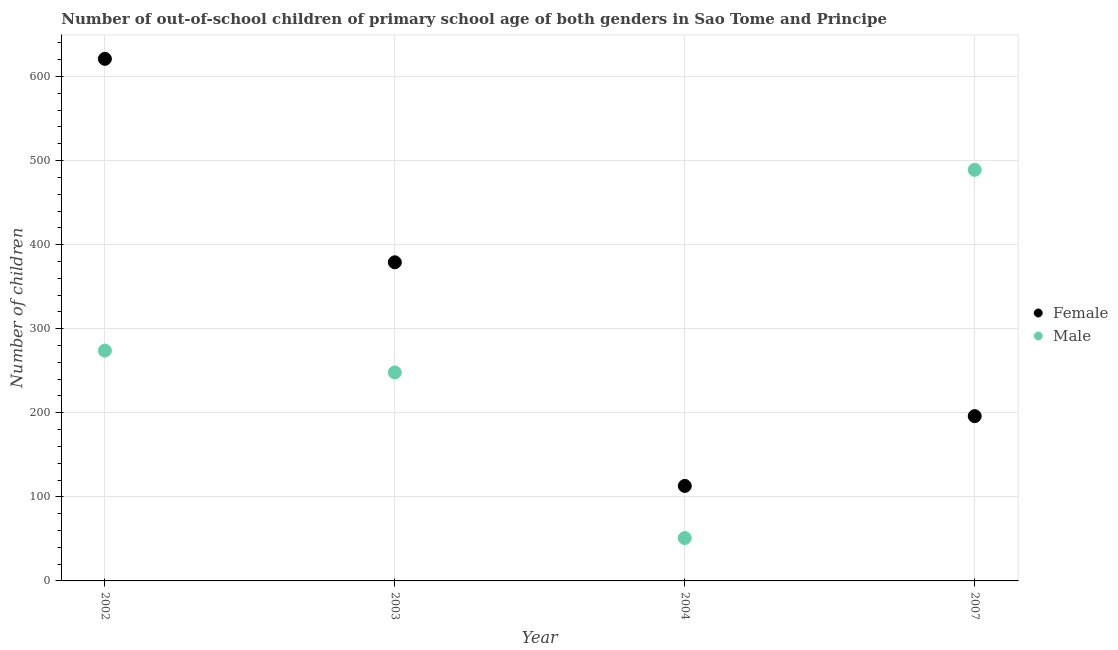Is the number of dotlines equal to the number of legend labels?
Your response must be concise. Yes. What is the number of female out-of-school students in 2007?
Offer a very short reply. 196. Across all years, what is the maximum number of female out-of-school students?
Your answer should be very brief. 621. Across all years, what is the minimum number of female out-of-school students?
Your response must be concise. 113. In which year was the number of female out-of-school students minimum?
Provide a succinct answer. 2004. What is the total number of male out-of-school students in the graph?
Give a very brief answer. 1062. What is the difference between the number of male out-of-school students in 2003 and that in 2004?
Give a very brief answer. 197. What is the difference between the number of male out-of-school students in 2007 and the number of female out-of-school students in 2004?
Make the answer very short. 376. What is the average number of female out-of-school students per year?
Offer a terse response. 327.25. In the year 2007, what is the difference between the number of male out-of-school students and number of female out-of-school students?
Offer a terse response. 293. What is the ratio of the number of female out-of-school students in 2002 to that in 2004?
Your answer should be compact. 5.5. Is the number of female out-of-school students in 2002 less than that in 2004?
Make the answer very short. No. What is the difference between the highest and the second highest number of male out-of-school students?
Your answer should be compact. 215. What is the difference between the highest and the lowest number of male out-of-school students?
Keep it short and to the point. 438. In how many years, is the number of male out-of-school students greater than the average number of male out-of-school students taken over all years?
Offer a very short reply. 2. Is the sum of the number of female out-of-school students in 2002 and 2003 greater than the maximum number of male out-of-school students across all years?
Offer a very short reply. Yes. Does the number of female out-of-school students monotonically increase over the years?
Keep it short and to the point. No. How many dotlines are there?
Ensure brevity in your answer.  2. What is the difference between two consecutive major ticks on the Y-axis?
Keep it short and to the point. 100. Are the values on the major ticks of Y-axis written in scientific E-notation?
Your response must be concise. No. Does the graph contain any zero values?
Give a very brief answer. No. Where does the legend appear in the graph?
Your answer should be very brief. Center right. What is the title of the graph?
Give a very brief answer. Number of out-of-school children of primary school age of both genders in Sao Tome and Principe. What is the label or title of the Y-axis?
Your answer should be compact. Number of children. What is the Number of children in Female in 2002?
Give a very brief answer. 621. What is the Number of children of Male in 2002?
Your response must be concise. 274. What is the Number of children of Female in 2003?
Provide a succinct answer. 379. What is the Number of children in Male in 2003?
Your response must be concise. 248. What is the Number of children in Female in 2004?
Provide a succinct answer. 113. What is the Number of children in Female in 2007?
Keep it short and to the point. 196. What is the Number of children of Male in 2007?
Your answer should be very brief. 489. Across all years, what is the maximum Number of children of Female?
Ensure brevity in your answer.  621. Across all years, what is the maximum Number of children of Male?
Make the answer very short. 489. Across all years, what is the minimum Number of children of Female?
Your answer should be compact. 113. What is the total Number of children of Female in the graph?
Offer a very short reply. 1309. What is the total Number of children of Male in the graph?
Provide a short and direct response. 1062. What is the difference between the Number of children in Female in 2002 and that in 2003?
Ensure brevity in your answer.  242. What is the difference between the Number of children of Female in 2002 and that in 2004?
Your answer should be very brief. 508. What is the difference between the Number of children of Male in 2002 and that in 2004?
Provide a short and direct response. 223. What is the difference between the Number of children of Female in 2002 and that in 2007?
Provide a short and direct response. 425. What is the difference between the Number of children in Male in 2002 and that in 2007?
Your answer should be compact. -215. What is the difference between the Number of children of Female in 2003 and that in 2004?
Give a very brief answer. 266. What is the difference between the Number of children in Male in 2003 and that in 2004?
Your answer should be compact. 197. What is the difference between the Number of children of Female in 2003 and that in 2007?
Make the answer very short. 183. What is the difference between the Number of children in Male in 2003 and that in 2007?
Give a very brief answer. -241. What is the difference between the Number of children in Female in 2004 and that in 2007?
Provide a short and direct response. -83. What is the difference between the Number of children of Male in 2004 and that in 2007?
Your answer should be very brief. -438. What is the difference between the Number of children in Female in 2002 and the Number of children in Male in 2003?
Offer a very short reply. 373. What is the difference between the Number of children of Female in 2002 and the Number of children of Male in 2004?
Offer a terse response. 570. What is the difference between the Number of children in Female in 2002 and the Number of children in Male in 2007?
Offer a terse response. 132. What is the difference between the Number of children of Female in 2003 and the Number of children of Male in 2004?
Offer a terse response. 328. What is the difference between the Number of children in Female in 2003 and the Number of children in Male in 2007?
Make the answer very short. -110. What is the difference between the Number of children in Female in 2004 and the Number of children in Male in 2007?
Offer a terse response. -376. What is the average Number of children of Female per year?
Your response must be concise. 327.25. What is the average Number of children of Male per year?
Offer a very short reply. 265.5. In the year 2002, what is the difference between the Number of children in Female and Number of children in Male?
Offer a very short reply. 347. In the year 2003, what is the difference between the Number of children in Female and Number of children in Male?
Offer a very short reply. 131. In the year 2004, what is the difference between the Number of children in Female and Number of children in Male?
Give a very brief answer. 62. In the year 2007, what is the difference between the Number of children of Female and Number of children of Male?
Give a very brief answer. -293. What is the ratio of the Number of children in Female in 2002 to that in 2003?
Offer a very short reply. 1.64. What is the ratio of the Number of children in Male in 2002 to that in 2003?
Your response must be concise. 1.1. What is the ratio of the Number of children in Female in 2002 to that in 2004?
Give a very brief answer. 5.5. What is the ratio of the Number of children of Male in 2002 to that in 2004?
Offer a terse response. 5.37. What is the ratio of the Number of children in Female in 2002 to that in 2007?
Give a very brief answer. 3.17. What is the ratio of the Number of children in Male in 2002 to that in 2007?
Make the answer very short. 0.56. What is the ratio of the Number of children in Female in 2003 to that in 2004?
Ensure brevity in your answer.  3.35. What is the ratio of the Number of children in Male in 2003 to that in 2004?
Provide a succinct answer. 4.86. What is the ratio of the Number of children in Female in 2003 to that in 2007?
Offer a terse response. 1.93. What is the ratio of the Number of children in Male in 2003 to that in 2007?
Keep it short and to the point. 0.51. What is the ratio of the Number of children of Female in 2004 to that in 2007?
Your response must be concise. 0.58. What is the ratio of the Number of children of Male in 2004 to that in 2007?
Ensure brevity in your answer.  0.1. What is the difference between the highest and the second highest Number of children in Female?
Your response must be concise. 242. What is the difference between the highest and the second highest Number of children in Male?
Keep it short and to the point. 215. What is the difference between the highest and the lowest Number of children of Female?
Offer a very short reply. 508. What is the difference between the highest and the lowest Number of children of Male?
Your answer should be very brief. 438. 